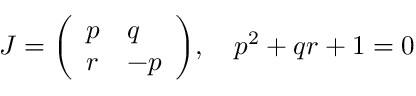Convert formula to latex. <formula><loc_0><loc_0><loc_500><loc_500>J = { \left ( \begin{array} { l l } { p } & { q } \\ { r } & { - p } \end{array} \right ) } , \quad p ^ { 2 } + q r + 1 = 0</formula> 